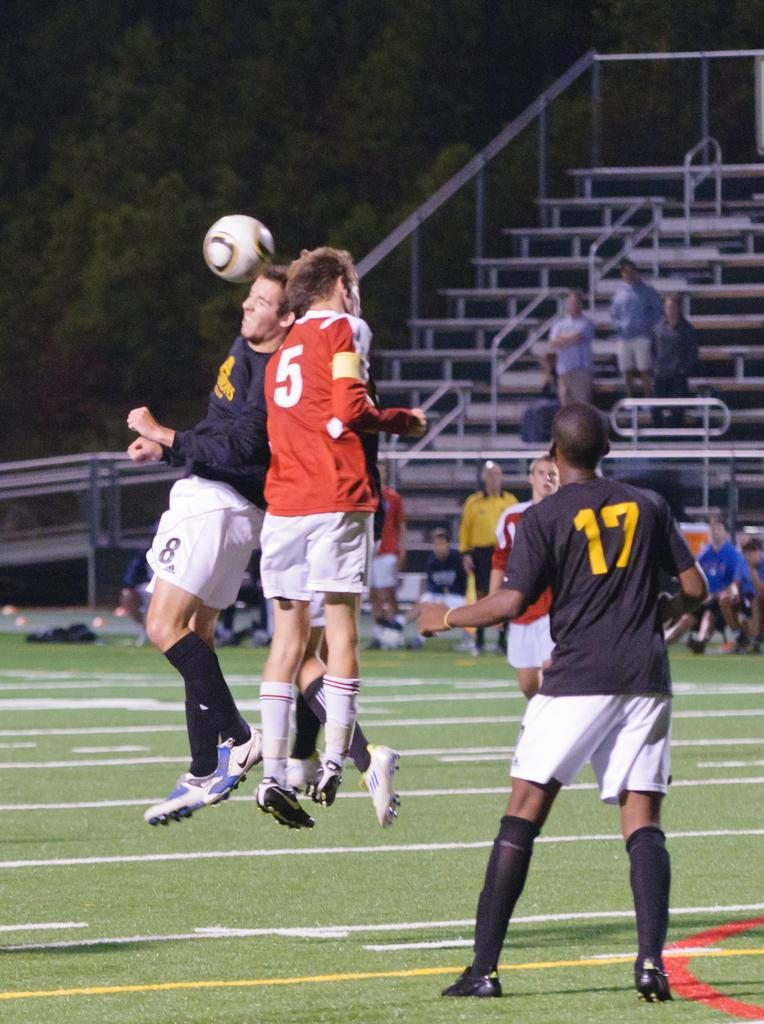<image>
Present a compact description of the photo's key features. A man in a red soccer jersey with 5 on the back headbutts another soccer player as they try and get the ball. 